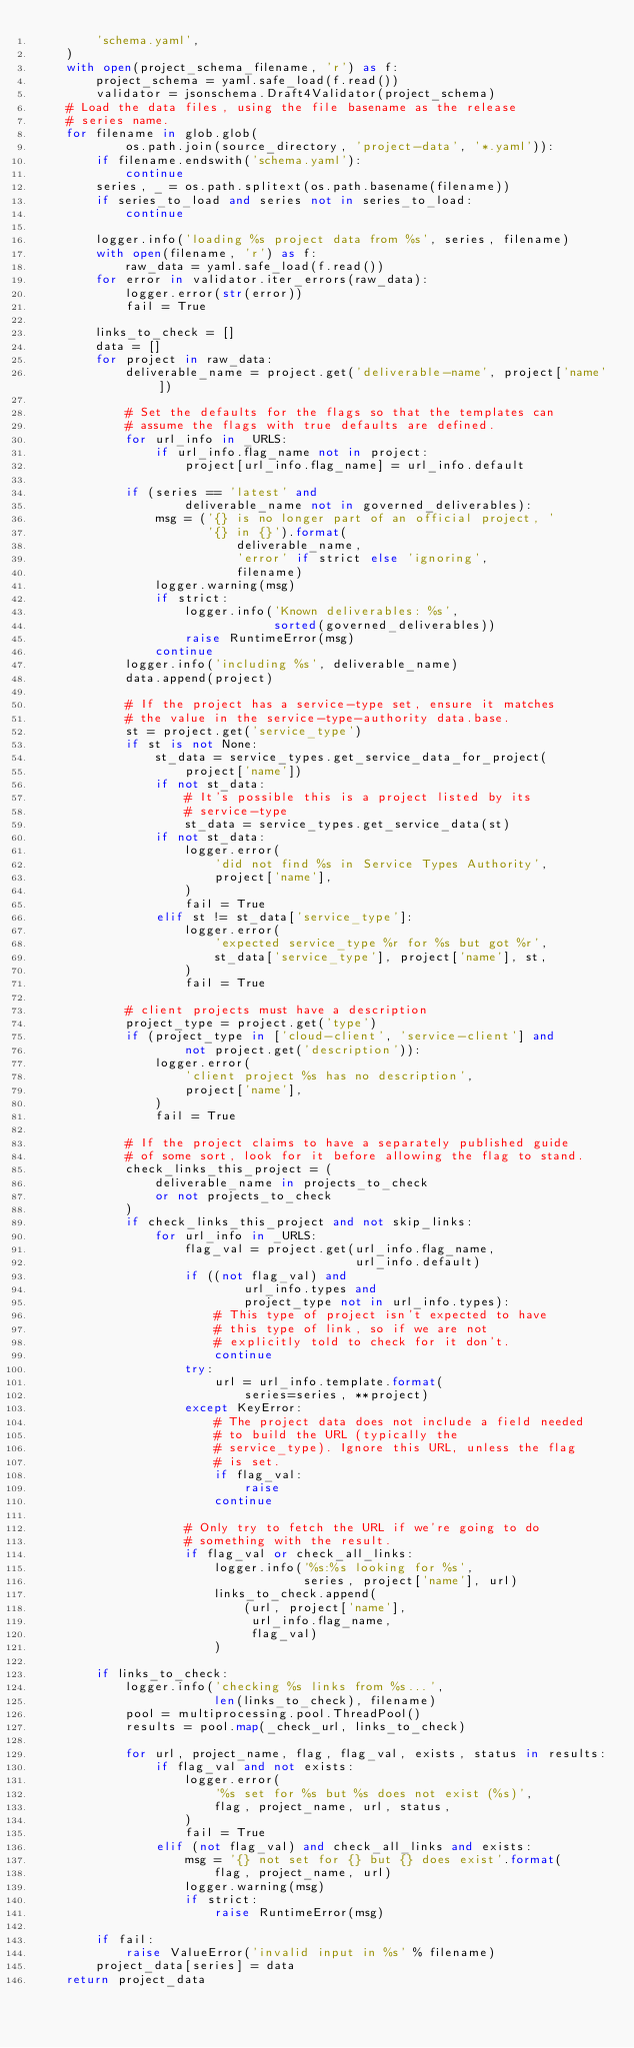<code> <loc_0><loc_0><loc_500><loc_500><_Python_>        'schema.yaml',
    )
    with open(project_schema_filename, 'r') as f:
        project_schema = yaml.safe_load(f.read())
        validator = jsonschema.Draft4Validator(project_schema)
    # Load the data files, using the file basename as the release
    # series name.
    for filename in glob.glob(
            os.path.join(source_directory, 'project-data', '*.yaml')):
        if filename.endswith('schema.yaml'):
            continue
        series, _ = os.path.splitext(os.path.basename(filename))
        if series_to_load and series not in series_to_load:
            continue

        logger.info('loading %s project data from %s', series, filename)
        with open(filename, 'r') as f:
            raw_data = yaml.safe_load(f.read())
        for error in validator.iter_errors(raw_data):
            logger.error(str(error))
            fail = True

        links_to_check = []
        data = []
        for project in raw_data:
            deliverable_name = project.get('deliverable-name', project['name'])

            # Set the defaults for the flags so that the templates can
            # assume the flags with true defaults are defined.
            for url_info in _URLS:
                if url_info.flag_name not in project:
                    project[url_info.flag_name] = url_info.default

            if (series == 'latest' and
                    deliverable_name not in governed_deliverables):
                msg = ('{} is no longer part of an official project, '
                       '{} in {}').format(
                           deliverable_name,
                           'error' if strict else 'ignoring',
                           filename)
                logger.warning(msg)
                if strict:
                    logger.info('Known deliverables: %s',
                                sorted(governed_deliverables))
                    raise RuntimeError(msg)
                continue
            logger.info('including %s', deliverable_name)
            data.append(project)

            # If the project has a service-type set, ensure it matches
            # the value in the service-type-authority data.base.
            st = project.get('service_type')
            if st is not None:
                st_data = service_types.get_service_data_for_project(
                    project['name'])
                if not st_data:
                    # It's possible this is a project listed by its
                    # service-type
                    st_data = service_types.get_service_data(st)
                if not st_data:
                    logger.error(
                        'did not find %s in Service Types Authority',
                        project['name'],
                    )
                    fail = True
                elif st != st_data['service_type']:
                    logger.error(
                        'expected service_type %r for %s but got %r',
                        st_data['service_type'], project['name'], st,
                    )
                    fail = True

            # client projects must have a description
            project_type = project.get('type')
            if (project_type in ['cloud-client', 'service-client'] and
                    not project.get('description')):
                logger.error(
                    'client project %s has no description',
                    project['name'],
                )
                fail = True

            # If the project claims to have a separately published guide
            # of some sort, look for it before allowing the flag to stand.
            check_links_this_project = (
                deliverable_name in projects_to_check
                or not projects_to_check
            )
            if check_links_this_project and not skip_links:
                for url_info in _URLS:
                    flag_val = project.get(url_info.flag_name,
                                           url_info.default)
                    if ((not flag_val) and
                            url_info.types and
                            project_type not in url_info.types):
                        # This type of project isn't expected to have
                        # this type of link, so if we are not
                        # explicitly told to check for it don't.
                        continue
                    try:
                        url = url_info.template.format(
                            series=series, **project)
                    except KeyError:
                        # The project data does not include a field needed
                        # to build the URL (typically the
                        # service_type). Ignore this URL, unless the flag
                        # is set.
                        if flag_val:
                            raise
                        continue

                    # Only try to fetch the URL if we're going to do
                    # something with the result.
                    if flag_val or check_all_links:
                        logger.info('%s:%s looking for %s',
                                    series, project['name'], url)
                        links_to_check.append(
                            (url, project['name'],
                             url_info.flag_name,
                             flag_val)
                        )

        if links_to_check:
            logger.info('checking %s links from %s...',
                        len(links_to_check), filename)
            pool = multiprocessing.pool.ThreadPool()
            results = pool.map(_check_url, links_to_check)

            for url, project_name, flag, flag_val, exists, status in results:
                if flag_val and not exists:
                    logger.error(
                        '%s set for %s but %s does not exist (%s)',
                        flag, project_name, url, status,
                    )
                    fail = True
                elif (not flag_val) and check_all_links and exists:
                    msg = '{} not set for {} but {} does exist'.format(
                        flag, project_name, url)
                    logger.warning(msg)
                    if strict:
                        raise RuntimeError(msg)

        if fail:
            raise ValueError('invalid input in %s' % filename)
        project_data[series] = data
    return project_data

</code> 